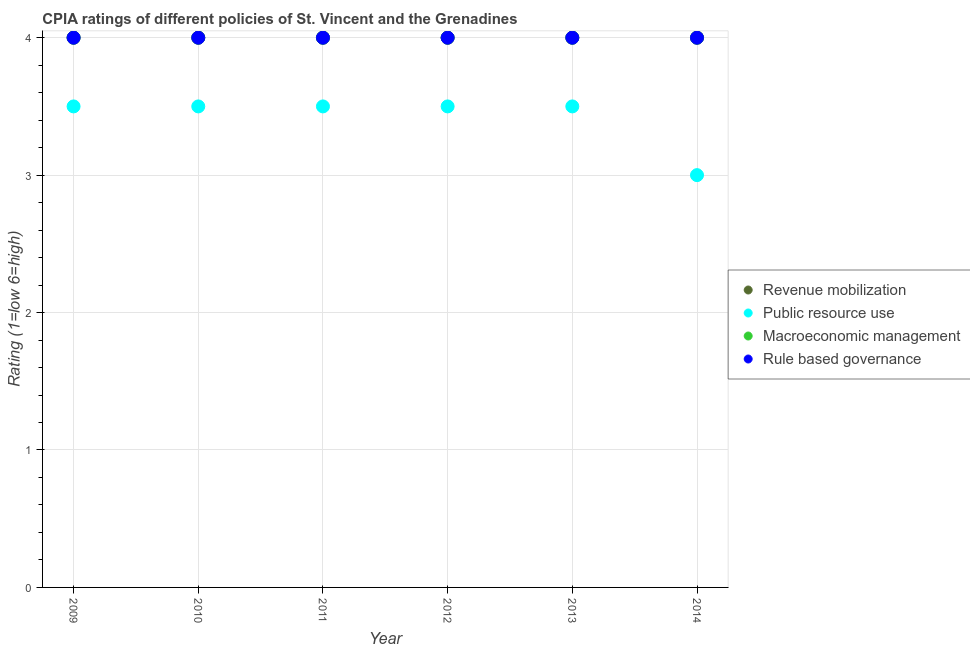How many different coloured dotlines are there?
Offer a very short reply. 4. What is the cpia rating of rule based governance in 2014?
Offer a terse response. 4. Across all years, what is the maximum cpia rating of macroeconomic management?
Your answer should be compact. 4. Across all years, what is the minimum cpia rating of rule based governance?
Provide a short and direct response. 4. What is the difference between the cpia rating of rule based governance in 2014 and the cpia rating of revenue mobilization in 2013?
Offer a very short reply. 0. What is the average cpia rating of rule based governance per year?
Your answer should be very brief. 4. In the year 2014, what is the difference between the cpia rating of revenue mobilization and cpia rating of macroeconomic management?
Your answer should be very brief. 0. In how many years, is the cpia rating of rule based governance greater than 2.6?
Your answer should be very brief. 6. Is the sum of the cpia rating of rule based governance in 2009 and 2012 greater than the maximum cpia rating of public resource use across all years?
Your answer should be very brief. Yes. Is it the case that in every year, the sum of the cpia rating of public resource use and cpia rating of revenue mobilization is greater than the sum of cpia rating of macroeconomic management and cpia rating of rule based governance?
Make the answer very short. No. Is it the case that in every year, the sum of the cpia rating of revenue mobilization and cpia rating of public resource use is greater than the cpia rating of macroeconomic management?
Your response must be concise. Yes. How many dotlines are there?
Provide a short and direct response. 4. What is the difference between two consecutive major ticks on the Y-axis?
Make the answer very short. 1. Are the values on the major ticks of Y-axis written in scientific E-notation?
Your answer should be very brief. No. Does the graph contain any zero values?
Your answer should be compact. No. Does the graph contain grids?
Provide a succinct answer. Yes. How are the legend labels stacked?
Provide a short and direct response. Vertical. What is the title of the graph?
Your response must be concise. CPIA ratings of different policies of St. Vincent and the Grenadines. Does "Negligence towards children" appear as one of the legend labels in the graph?
Your answer should be compact. No. What is the label or title of the X-axis?
Your response must be concise. Year. What is the Rating (1=low 6=high) of Public resource use in 2009?
Your answer should be very brief. 3.5. What is the Rating (1=low 6=high) in Revenue mobilization in 2011?
Give a very brief answer. 4. What is the Rating (1=low 6=high) of Public resource use in 2011?
Offer a very short reply. 3.5. What is the Rating (1=low 6=high) of Revenue mobilization in 2012?
Ensure brevity in your answer.  4. What is the Rating (1=low 6=high) in Rule based governance in 2012?
Provide a short and direct response. 4. What is the Rating (1=low 6=high) of Revenue mobilization in 2013?
Offer a very short reply. 4. What is the Rating (1=low 6=high) of Public resource use in 2014?
Ensure brevity in your answer.  3. Across all years, what is the maximum Rating (1=low 6=high) of Macroeconomic management?
Ensure brevity in your answer.  4. What is the total Rating (1=low 6=high) in Revenue mobilization in the graph?
Your response must be concise. 24. What is the total Rating (1=low 6=high) of Public resource use in the graph?
Keep it short and to the point. 20.5. What is the difference between the Rating (1=low 6=high) in Revenue mobilization in 2009 and that in 2010?
Give a very brief answer. 0. What is the difference between the Rating (1=low 6=high) of Public resource use in 2009 and that in 2010?
Make the answer very short. 0. What is the difference between the Rating (1=low 6=high) of Macroeconomic management in 2009 and that in 2010?
Your answer should be very brief. 0. What is the difference between the Rating (1=low 6=high) of Revenue mobilization in 2009 and that in 2011?
Provide a short and direct response. 0. What is the difference between the Rating (1=low 6=high) in Public resource use in 2009 and that in 2011?
Your answer should be compact. 0. What is the difference between the Rating (1=low 6=high) of Macroeconomic management in 2009 and that in 2011?
Provide a succinct answer. 0. What is the difference between the Rating (1=low 6=high) in Revenue mobilization in 2009 and that in 2012?
Ensure brevity in your answer.  0. What is the difference between the Rating (1=low 6=high) in Rule based governance in 2009 and that in 2012?
Your answer should be very brief. 0. What is the difference between the Rating (1=low 6=high) of Public resource use in 2009 and that in 2013?
Provide a short and direct response. 0. What is the difference between the Rating (1=low 6=high) of Macroeconomic management in 2009 and that in 2013?
Your answer should be very brief. 0. What is the difference between the Rating (1=low 6=high) in Revenue mobilization in 2009 and that in 2014?
Provide a short and direct response. 0. What is the difference between the Rating (1=low 6=high) of Public resource use in 2009 and that in 2014?
Keep it short and to the point. 0.5. What is the difference between the Rating (1=low 6=high) in Public resource use in 2010 and that in 2011?
Your answer should be very brief. 0. What is the difference between the Rating (1=low 6=high) of Macroeconomic management in 2010 and that in 2011?
Offer a very short reply. 0. What is the difference between the Rating (1=low 6=high) in Rule based governance in 2010 and that in 2011?
Your answer should be compact. 0. What is the difference between the Rating (1=low 6=high) in Public resource use in 2010 and that in 2012?
Ensure brevity in your answer.  0. What is the difference between the Rating (1=low 6=high) in Macroeconomic management in 2010 and that in 2012?
Your answer should be compact. 0. What is the difference between the Rating (1=low 6=high) of Rule based governance in 2010 and that in 2012?
Offer a very short reply. 0. What is the difference between the Rating (1=low 6=high) of Revenue mobilization in 2010 and that in 2013?
Your answer should be very brief. 0. What is the difference between the Rating (1=low 6=high) in Revenue mobilization in 2010 and that in 2014?
Your answer should be compact. 0. What is the difference between the Rating (1=low 6=high) of Macroeconomic management in 2010 and that in 2014?
Offer a terse response. 0. What is the difference between the Rating (1=low 6=high) of Revenue mobilization in 2011 and that in 2012?
Your answer should be very brief. 0. What is the difference between the Rating (1=low 6=high) in Public resource use in 2011 and that in 2012?
Ensure brevity in your answer.  0. What is the difference between the Rating (1=low 6=high) in Public resource use in 2011 and that in 2013?
Provide a succinct answer. 0. What is the difference between the Rating (1=low 6=high) of Macroeconomic management in 2011 and that in 2013?
Offer a very short reply. 0. What is the difference between the Rating (1=low 6=high) of Revenue mobilization in 2011 and that in 2014?
Provide a succinct answer. 0. What is the difference between the Rating (1=low 6=high) of Public resource use in 2011 and that in 2014?
Offer a terse response. 0.5. What is the difference between the Rating (1=low 6=high) of Revenue mobilization in 2012 and that in 2013?
Your response must be concise. 0. What is the difference between the Rating (1=low 6=high) of Macroeconomic management in 2012 and that in 2013?
Make the answer very short. 0. What is the difference between the Rating (1=low 6=high) of Macroeconomic management in 2012 and that in 2014?
Keep it short and to the point. 0. What is the difference between the Rating (1=low 6=high) in Revenue mobilization in 2013 and that in 2014?
Make the answer very short. 0. What is the difference between the Rating (1=low 6=high) of Revenue mobilization in 2009 and the Rating (1=low 6=high) of Rule based governance in 2010?
Your answer should be compact. 0. What is the difference between the Rating (1=low 6=high) of Public resource use in 2009 and the Rating (1=low 6=high) of Macroeconomic management in 2010?
Keep it short and to the point. -0.5. What is the difference between the Rating (1=low 6=high) in Revenue mobilization in 2009 and the Rating (1=low 6=high) in Public resource use in 2011?
Keep it short and to the point. 0.5. What is the difference between the Rating (1=low 6=high) of Revenue mobilization in 2009 and the Rating (1=low 6=high) of Rule based governance in 2011?
Make the answer very short. 0. What is the difference between the Rating (1=low 6=high) of Revenue mobilization in 2009 and the Rating (1=low 6=high) of Macroeconomic management in 2012?
Provide a short and direct response. 0. What is the difference between the Rating (1=low 6=high) in Revenue mobilization in 2009 and the Rating (1=low 6=high) in Rule based governance in 2012?
Offer a very short reply. 0. What is the difference between the Rating (1=low 6=high) of Public resource use in 2009 and the Rating (1=low 6=high) of Rule based governance in 2013?
Make the answer very short. -0.5. What is the difference between the Rating (1=low 6=high) in Revenue mobilization in 2009 and the Rating (1=low 6=high) in Public resource use in 2014?
Keep it short and to the point. 1. What is the difference between the Rating (1=low 6=high) of Public resource use in 2009 and the Rating (1=low 6=high) of Macroeconomic management in 2014?
Give a very brief answer. -0.5. What is the difference between the Rating (1=low 6=high) in Public resource use in 2009 and the Rating (1=low 6=high) in Rule based governance in 2014?
Your answer should be compact. -0.5. What is the difference between the Rating (1=low 6=high) in Macroeconomic management in 2009 and the Rating (1=low 6=high) in Rule based governance in 2014?
Offer a very short reply. 0. What is the difference between the Rating (1=low 6=high) in Revenue mobilization in 2010 and the Rating (1=low 6=high) in Public resource use in 2011?
Your answer should be very brief. 0.5. What is the difference between the Rating (1=low 6=high) of Revenue mobilization in 2010 and the Rating (1=low 6=high) of Macroeconomic management in 2011?
Ensure brevity in your answer.  0. What is the difference between the Rating (1=low 6=high) of Revenue mobilization in 2010 and the Rating (1=low 6=high) of Rule based governance in 2011?
Keep it short and to the point. 0. What is the difference between the Rating (1=low 6=high) in Public resource use in 2010 and the Rating (1=low 6=high) in Macroeconomic management in 2011?
Ensure brevity in your answer.  -0.5. What is the difference between the Rating (1=low 6=high) in Public resource use in 2010 and the Rating (1=low 6=high) in Rule based governance in 2011?
Ensure brevity in your answer.  -0.5. What is the difference between the Rating (1=low 6=high) in Macroeconomic management in 2010 and the Rating (1=low 6=high) in Rule based governance in 2011?
Ensure brevity in your answer.  0. What is the difference between the Rating (1=low 6=high) of Public resource use in 2010 and the Rating (1=low 6=high) of Rule based governance in 2012?
Make the answer very short. -0.5. What is the difference between the Rating (1=low 6=high) of Macroeconomic management in 2010 and the Rating (1=low 6=high) of Rule based governance in 2012?
Your answer should be very brief. 0. What is the difference between the Rating (1=low 6=high) in Revenue mobilization in 2010 and the Rating (1=low 6=high) in Public resource use in 2013?
Keep it short and to the point. 0.5. What is the difference between the Rating (1=low 6=high) in Revenue mobilization in 2010 and the Rating (1=low 6=high) in Macroeconomic management in 2013?
Provide a succinct answer. 0. What is the difference between the Rating (1=low 6=high) in Revenue mobilization in 2010 and the Rating (1=low 6=high) in Rule based governance in 2013?
Keep it short and to the point. 0. What is the difference between the Rating (1=low 6=high) in Public resource use in 2010 and the Rating (1=low 6=high) in Macroeconomic management in 2013?
Your answer should be compact. -0.5. What is the difference between the Rating (1=low 6=high) in Public resource use in 2010 and the Rating (1=low 6=high) in Rule based governance in 2013?
Give a very brief answer. -0.5. What is the difference between the Rating (1=low 6=high) in Macroeconomic management in 2010 and the Rating (1=low 6=high) in Rule based governance in 2013?
Your answer should be compact. 0. What is the difference between the Rating (1=low 6=high) in Revenue mobilization in 2010 and the Rating (1=low 6=high) in Macroeconomic management in 2014?
Offer a terse response. 0. What is the difference between the Rating (1=low 6=high) in Public resource use in 2010 and the Rating (1=low 6=high) in Rule based governance in 2014?
Make the answer very short. -0.5. What is the difference between the Rating (1=low 6=high) of Revenue mobilization in 2011 and the Rating (1=low 6=high) of Macroeconomic management in 2012?
Provide a succinct answer. 0. What is the difference between the Rating (1=low 6=high) in Public resource use in 2011 and the Rating (1=low 6=high) in Macroeconomic management in 2012?
Provide a short and direct response. -0.5. What is the difference between the Rating (1=low 6=high) in Macroeconomic management in 2011 and the Rating (1=low 6=high) in Rule based governance in 2012?
Ensure brevity in your answer.  0. What is the difference between the Rating (1=low 6=high) in Revenue mobilization in 2011 and the Rating (1=low 6=high) in Public resource use in 2013?
Offer a very short reply. 0.5. What is the difference between the Rating (1=low 6=high) of Revenue mobilization in 2011 and the Rating (1=low 6=high) of Rule based governance in 2013?
Provide a succinct answer. 0. What is the difference between the Rating (1=low 6=high) in Macroeconomic management in 2011 and the Rating (1=low 6=high) in Rule based governance in 2013?
Give a very brief answer. 0. What is the difference between the Rating (1=low 6=high) of Revenue mobilization in 2011 and the Rating (1=low 6=high) of Macroeconomic management in 2014?
Your answer should be very brief. 0. What is the difference between the Rating (1=low 6=high) of Revenue mobilization in 2011 and the Rating (1=low 6=high) of Rule based governance in 2014?
Keep it short and to the point. 0. What is the difference between the Rating (1=low 6=high) in Public resource use in 2011 and the Rating (1=low 6=high) in Rule based governance in 2014?
Give a very brief answer. -0.5. What is the difference between the Rating (1=low 6=high) in Macroeconomic management in 2011 and the Rating (1=low 6=high) in Rule based governance in 2014?
Keep it short and to the point. 0. What is the difference between the Rating (1=low 6=high) in Revenue mobilization in 2012 and the Rating (1=low 6=high) in Macroeconomic management in 2013?
Offer a very short reply. 0. What is the difference between the Rating (1=low 6=high) in Revenue mobilization in 2012 and the Rating (1=low 6=high) in Rule based governance in 2013?
Offer a terse response. 0. What is the difference between the Rating (1=low 6=high) in Public resource use in 2012 and the Rating (1=low 6=high) in Macroeconomic management in 2013?
Your response must be concise. -0.5. What is the difference between the Rating (1=low 6=high) in Public resource use in 2012 and the Rating (1=low 6=high) in Rule based governance in 2013?
Offer a very short reply. -0.5. What is the difference between the Rating (1=low 6=high) in Revenue mobilization in 2012 and the Rating (1=low 6=high) in Rule based governance in 2014?
Your response must be concise. 0. What is the difference between the Rating (1=low 6=high) of Public resource use in 2012 and the Rating (1=low 6=high) of Macroeconomic management in 2014?
Make the answer very short. -0.5. What is the difference between the Rating (1=low 6=high) in Public resource use in 2012 and the Rating (1=low 6=high) in Rule based governance in 2014?
Keep it short and to the point. -0.5. What is the difference between the Rating (1=low 6=high) of Macroeconomic management in 2012 and the Rating (1=low 6=high) of Rule based governance in 2014?
Your answer should be compact. 0. What is the difference between the Rating (1=low 6=high) in Revenue mobilization in 2013 and the Rating (1=low 6=high) in Public resource use in 2014?
Your answer should be very brief. 1. What is the difference between the Rating (1=low 6=high) of Revenue mobilization in 2013 and the Rating (1=low 6=high) of Rule based governance in 2014?
Offer a very short reply. 0. What is the difference between the Rating (1=low 6=high) of Public resource use in 2013 and the Rating (1=low 6=high) of Macroeconomic management in 2014?
Your response must be concise. -0.5. What is the average Rating (1=low 6=high) of Public resource use per year?
Offer a terse response. 3.42. What is the average Rating (1=low 6=high) of Macroeconomic management per year?
Make the answer very short. 4. What is the average Rating (1=low 6=high) in Rule based governance per year?
Your answer should be very brief. 4. In the year 2010, what is the difference between the Rating (1=low 6=high) of Revenue mobilization and Rating (1=low 6=high) of Macroeconomic management?
Provide a short and direct response. 0. In the year 2010, what is the difference between the Rating (1=low 6=high) of Revenue mobilization and Rating (1=low 6=high) of Rule based governance?
Give a very brief answer. 0. In the year 2010, what is the difference between the Rating (1=low 6=high) of Macroeconomic management and Rating (1=low 6=high) of Rule based governance?
Provide a short and direct response. 0. In the year 2011, what is the difference between the Rating (1=low 6=high) of Revenue mobilization and Rating (1=low 6=high) of Public resource use?
Ensure brevity in your answer.  0.5. In the year 2011, what is the difference between the Rating (1=low 6=high) of Revenue mobilization and Rating (1=low 6=high) of Macroeconomic management?
Offer a very short reply. 0. In the year 2011, what is the difference between the Rating (1=low 6=high) of Macroeconomic management and Rating (1=low 6=high) of Rule based governance?
Offer a very short reply. 0. In the year 2012, what is the difference between the Rating (1=low 6=high) of Revenue mobilization and Rating (1=low 6=high) of Macroeconomic management?
Your answer should be very brief. 0. In the year 2012, what is the difference between the Rating (1=low 6=high) in Public resource use and Rating (1=low 6=high) in Macroeconomic management?
Offer a terse response. -0.5. In the year 2012, what is the difference between the Rating (1=low 6=high) of Public resource use and Rating (1=low 6=high) of Rule based governance?
Your answer should be compact. -0.5. In the year 2012, what is the difference between the Rating (1=low 6=high) of Macroeconomic management and Rating (1=low 6=high) of Rule based governance?
Offer a terse response. 0. In the year 2013, what is the difference between the Rating (1=low 6=high) in Revenue mobilization and Rating (1=low 6=high) in Public resource use?
Offer a very short reply. 0.5. In the year 2013, what is the difference between the Rating (1=low 6=high) in Revenue mobilization and Rating (1=low 6=high) in Macroeconomic management?
Provide a succinct answer. 0. In the year 2013, what is the difference between the Rating (1=low 6=high) in Public resource use and Rating (1=low 6=high) in Macroeconomic management?
Keep it short and to the point. -0.5. In the year 2013, what is the difference between the Rating (1=low 6=high) of Public resource use and Rating (1=low 6=high) of Rule based governance?
Your answer should be compact. -0.5. In the year 2014, what is the difference between the Rating (1=low 6=high) of Revenue mobilization and Rating (1=low 6=high) of Public resource use?
Make the answer very short. 1. In the year 2014, what is the difference between the Rating (1=low 6=high) in Revenue mobilization and Rating (1=low 6=high) in Macroeconomic management?
Give a very brief answer. 0. In the year 2014, what is the difference between the Rating (1=low 6=high) of Public resource use and Rating (1=low 6=high) of Rule based governance?
Your response must be concise. -1. In the year 2014, what is the difference between the Rating (1=low 6=high) in Macroeconomic management and Rating (1=low 6=high) in Rule based governance?
Your answer should be very brief. 0. What is the ratio of the Rating (1=low 6=high) of Revenue mobilization in 2009 to that in 2010?
Provide a succinct answer. 1. What is the ratio of the Rating (1=low 6=high) of Public resource use in 2009 to that in 2010?
Keep it short and to the point. 1. What is the ratio of the Rating (1=low 6=high) of Rule based governance in 2009 to that in 2010?
Give a very brief answer. 1. What is the ratio of the Rating (1=low 6=high) of Revenue mobilization in 2009 to that in 2011?
Your answer should be very brief. 1. What is the ratio of the Rating (1=low 6=high) in Rule based governance in 2009 to that in 2011?
Your answer should be very brief. 1. What is the ratio of the Rating (1=low 6=high) of Public resource use in 2009 to that in 2012?
Give a very brief answer. 1. What is the ratio of the Rating (1=low 6=high) of Revenue mobilization in 2009 to that in 2013?
Give a very brief answer. 1. What is the ratio of the Rating (1=low 6=high) in Public resource use in 2009 to that in 2013?
Your answer should be very brief. 1. What is the ratio of the Rating (1=low 6=high) in Macroeconomic management in 2009 to that in 2013?
Your answer should be very brief. 1. What is the ratio of the Rating (1=low 6=high) of Revenue mobilization in 2009 to that in 2014?
Offer a terse response. 1. What is the ratio of the Rating (1=low 6=high) in Public resource use in 2009 to that in 2014?
Offer a very short reply. 1.17. What is the ratio of the Rating (1=low 6=high) in Macroeconomic management in 2009 to that in 2014?
Ensure brevity in your answer.  1. What is the ratio of the Rating (1=low 6=high) in Rule based governance in 2009 to that in 2014?
Provide a short and direct response. 1. What is the ratio of the Rating (1=low 6=high) of Public resource use in 2010 to that in 2011?
Offer a terse response. 1. What is the ratio of the Rating (1=low 6=high) of Macroeconomic management in 2010 to that in 2011?
Give a very brief answer. 1. What is the ratio of the Rating (1=low 6=high) of Rule based governance in 2010 to that in 2012?
Give a very brief answer. 1. What is the ratio of the Rating (1=low 6=high) in Revenue mobilization in 2010 to that in 2013?
Offer a terse response. 1. What is the ratio of the Rating (1=low 6=high) in Public resource use in 2010 to that in 2013?
Give a very brief answer. 1. What is the ratio of the Rating (1=low 6=high) of Rule based governance in 2010 to that in 2013?
Offer a terse response. 1. What is the ratio of the Rating (1=low 6=high) of Revenue mobilization in 2010 to that in 2014?
Your answer should be very brief. 1. What is the ratio of the Rating (1=low 6=high) in Macroeconomic management in 2011 to that in 2012?
Make the answer very short. 1. What is the ratio of the Rating (1=low 6=high) in Rule based governance in 2011 to that in 2012?
Your response must be concise. 1. What is the ratio of the Rating (1=low 6=high) of Revenue mobilization in 2011 to that in 2014?
Your response must be concise. 1. What is the ratio of the Rating (1=low 6=high) of Public resource use in 2011 to that in 2014?
Your response must be concise. 1.17. What is the ratio of the Rating (1=low 6=high) in Revenue mobilization in 2012 to that in 2013?
Offer a terse response. 1. What is the ratio of the Rating (1=low 6=high) in Public resource use in 2012 to that in 2013?
Your response must be concise. 1. What is the ratio of the Rating (1=low 6=high) in Macroeconomic management in 2012 to that in 2013?
Make the answer very short. 1. What is the ratio of the Rating (1=low 6=high) of Revenue mobilization in 2013 to that in 2014?
Make the answer very short. 1. What is the ratio of the Rating (1=low 6=high) of Public resource use in 2013 to that in 2014?
Make the answer very short. 1.17. What is the ratio of the Rating (1=low 6=high) of Macroeconomic management in 2013 to that in 2014?
Your answer should be compact. 1. What is the ratio of the Rating (1=low 6=high) in Rule based governance in 2013 to that in 2014?
Your answer should be very brief. 1. What is the difference between the highest and the second highest Rating (1=low 6=high) in Public resource use?
Offer a very short reply. 0. What is the difference between the highest and the second highest Rating (1=low 6=high) in Macroeconomic management?
Your response must be concise. 0. What is the difference between the highest and the lowest Rating (1=low 6=high) in Revenue mobilization?
Your answer should be compact. 0. What is the difference between the highest and the lowest Rating (1=low 6=high) in Rule based governance?
Offer a very short reply. 0. 